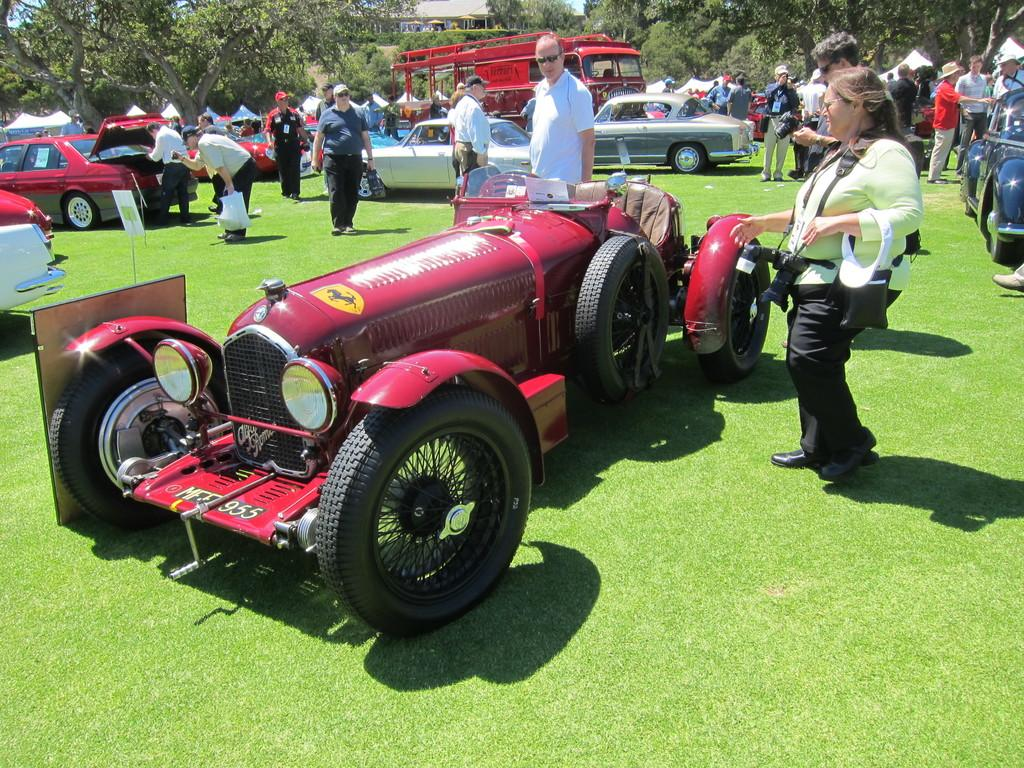What type of outdoor space is depicted in the image? There is a garden in the image. What unusual objects can be seen in the garden? Cars are present in the garden. What are the people in the garden doing? People are present in the garden and performing various activities. What can be seen in the distance in the image? Trees are visible in the background of the image. How much dust is visible on the cars in the image? There is no mention of dust in the image, and the cars do not appear to be dirty or dusty. What scientific discovery was made in the garden in the image? There is no indication of a scientific discovery being made in the image; it simply shows a garden with cars and people. 